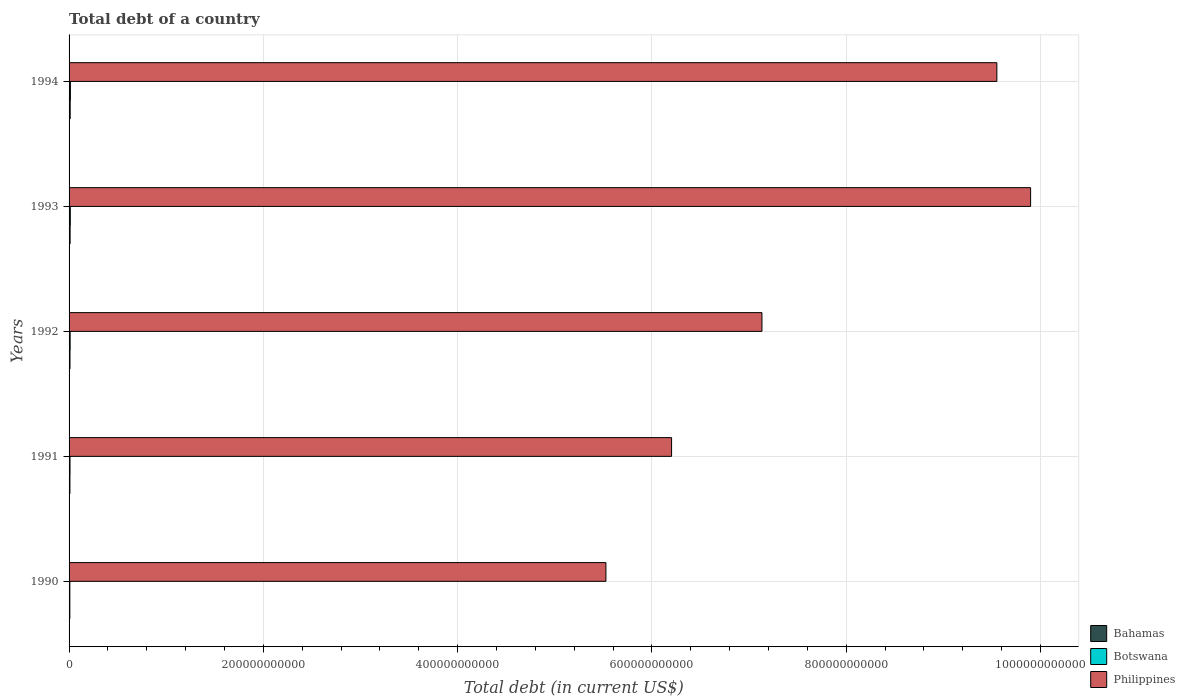How many different coloured bars are there?
Your answer should be very brief. 3. How many groups of bars are there?
Make the answer very short. 5. Are the number of bars per tick equal to the number of legend labels?
Provide a succinct answer. Yes. Are the number of bars on each tick of the Y-axis equal?
Your answer should be very brief. Yes. How many bars are there on the 5th tick from the top?
Make the answer very short. 3. What is the label of the 5th group of bars from the top?
Provide a short and direct response. 1990. In how many cases, is the number of bars for a given year not equal to the number of legend labels?
Offer a very short reply. 0. What is the debt in Bahamas in 1994?
Your response must be concise. 1.14e+09. Across all years, what is the maximum debt in Botswana?
Keep it short and to the point. 1.38e+09. Across all years, what is the minimum debt in Philippines?
Your answer should be very brief. 5.53e+11. In which year was the debt in Botswana maximum?
Make the answer very short. 1994. What is the total debt in Philippines in the graph?
Keep it short and to the point. 3.83e+12. What is the difference between the debt in Botswana in 1990 and that in 1993?
Offer a very short reply. -4.53e+08. What is the difference between the debt in Botswana in 1990 and the debt in Bahamas in 1994?
Offer a very short reply. -3.34e+08. What is the average debt in Botswana per year?
Offer a very short reply. 1.10e+09. In the year 1993, what is the difference between the debt in Bahamas and debt in Philippines?
Offer a very short reply. -9.89e+11. In how many years, is the debt in Botswana greater than 640000000000 US$?
Provide a succinct answer. 0. What is the ratio of the debt in Philippines in 1991 to that in 1992?
Your answer should be very brief. 0.87. Is the debt in Botswana in 1993 less than that in 1994?
Keep it short and to the point. Yes. What is the difference between the highest and the second highest debt in Philippines?
Give a very brief answer. 3.47e+1. What is the difference between the highest and the lowest debt in Philippines?
Make the answer very short. 4.37e+11. Is the sum of the debt in Botswana in 1993 and 1994 greater than the maximum debt in Philippines across all years?
Keep it short and to the point. No. What does the 1st bar from the top in 1993 represents?
Keep it short and to the point. Philippines. What does the 2nd bar from the bottom in 1993 represents?
Keep it short and to the point. Botswana. Are all the bars in the graph horizontal?
Ensure brevity in your answer.  Yes. What is the difference between two consecutive major ticks on the X-axis?
Provide a succinct answer. 2.00e+11. Are the values on the major ticks of X-axis written in scientific E-notation?
Provide a succinct answer. No. How many legend labels are there?
Your answer should be very brief. 3. What is the title of the graph?
Keep it short and to the point. Total debt of a country. What is the label or title of the X-axis?
Ensure brevity in your answer.  Total debt (in current US$). What is the label or title of the Y-axis?
Your response must be concise. Years. What is the Total debt (in current US$) of Bahamas in 1990?
Offer a terse response. 7.73e+08. What is the Total debt (in current US$) of Botswana in 1990?
Provide a short and direct response. 8.02e+08. What is the Total debt (in current US$) in Philippines in 1990?
Offer a very short reply. 5.53e+11. What is the Total debt (in current US$) of Bahamas in 1991?
Keep it short and to the point. 8.70e+08. What is the Total debt (in current US$) in Botswana in 1991?
Provide a short and direct response. 9.66e+08. What is the Total debt (in current US$) of Philippines in 1991?
Provide a succinct answer. 6.20e+11. What is the Total debt (in current US$) of Bahamas in 1992?
Your answer should be compact. 9.52e+08. What is the Total debt (in current US$) of Botswana in 1992?
Offer a very short reply. 1.10e+09. What is the Total debt (in current US$) in Philippines in 1992?
Make the answer very short. 7.13e+11. What is the Total debt (in current US$) of Bahamas in 1993?
Give a very brief answer. 1.06e+09. What is the Total debt (in current US$) of Botswana in 1993?
Give a very brief answer. 1.25e+09. What is the Total debt (in current US$) of Philippines in 1993?
Make the answer very short. 9.90e+11. What is the Total debt (in current US$) in Bahamas in 1994?
Your response must be concise. 1.14e+09. What is the Total debt (in current US$) of Botswana in 1994?
Offer a very short reply. 1.38e+09. What is the Total debt (in current US$) of Philippines in 1994?
Your answer should be compact. 9.55e+11. Across all years, what is the maximum Total debt (in current US$) of Bahamas?
Offer a very short reply. 1.14e+09. Across all years, what is the maximum Total debt (in current US$) of Botswana?
Your answer should be very brief. 1.38e+09. Across all years, what is the maximum Total debt (in current US$) in Philippines?
Give a very brief answer. 9.90e+11. Across all years, what is the minimum Total debt (in current US$) in Bahamas?
Offer a terse response. 7.73e+08. Across all years, what is the minimum Total debt (in current US$) of Botswana?
Provide a succinct answer. 8.02e+08. Across all years, what is the minimum Total debt (in current US$) of Philippines?
Keep it short and to the point. 5.53e+11. What is the total Total debt (in current US$) of Bahamas in the graph?
Offer a very short reply. 4.80e+09. What is the total Total debt (in current US$) of Botswana in the graph?
Your response must be concise. 5.50e+09. What is the total Total debt (in current US$) of Philippines in the graph?
Offer a very short reply. 3.83e+12. What is the difference between the Total debt (in current US$) of Bahamas in 1990 and that in 1991?
Provide a succinct answer. -9.73e+07. What is the difference between the Total debt (in current US$) of Botswana in 1990 and that in 1991?
Provide a succinct answer. -1.64e+08. What is the difference between the Total debt (in current US$) of Philippines in 1990 and that in 1991?
Provide a short and direct response. -6.76e+1. What is the difference between the Total debt (in current US$) in Bahamas in 1990 and that in 1992?
Give a very brief answer. -1.79e+08. What is the difference between the Total debt (in current US$) of Botswana in 1990 and that in 1992?
Your response must be concise. -2.94e+08. What is the difference between the Total debt (in current US$) of Philippines in 1990 and that in 1992?
Ensure brevity in your answer.  -1.61e+11. What is the difference between the Total debt (in current US$) of Bahamas in 1990 and that in 1993?
Give a very brief answer. -2.92e+08. What is the difference between the Total debt (in current US$) in Botswana in 1990 and that in 1993?
Provide a short and direct response. -4.53e+08. What is the difference between the Total debt (in current US$) of Philippines in 1990 and that in 1993?
Keep it short and to the point. -4.37e+11. What is the difference between the Total debt (in current US$) of Bahamas in 1990 and that in 1994?
Ensure brevity in your answer.  -3.63e+08. What is the difference between the Total debt (in current US$) in Botswana in 1990 and that in 1994?
Keep it short and to the point. -5.75e+08. What is the difference between the Total debt (in current US$) of Philippines in 1990 and that in 1994?
Your response must be concise. -4.02e+11. What is the difference between the Total debt (in current US$) of Bahamas in 1991 and that in 1992?
Make the answer very short. -8.19e+07. What is the difference between the Total debt (in current US$) in Botswana in 1991 and that in 1992?
Provide a short and direct response. -1.30e+08. What is the difference between the Total debt (in current US$) of Philippines in 1991 and that in 1992?
Provide a succinct answer. -9.30e+1. What is the difference between the Total debt (in current US$) in Bahamas in 1991 and that in 1993?
Your response must be concise. -1.94e+08. What is the difference between the Total debt (in current US$) in Botswana in 1991 and that in 1993?
Your response must be concise. -2.89e+08. What is the difference between the Total debt (in current US$) in Philippines in 1991 and that in 1993?
Keep it short and to the point. -3.70e+11. What is the difference between the Total debt (in current US$) in Bahamas in 1991 and that in 1994?
Offer a terse response. -2.66e+08. What is the difference between the Total debt (in current US$) in Botswana in 1991 and that in 1994?
Provide a short and direct response. -4.11e+08. What is the difference between the Total debt (in current US$) in Philippines in 1991 and that in 1994?
Give a very brief answer. -3.35e+11. What is the difference between the Total debt (in current US$) in Bahamas in 1992 and that in 1993?
Keep it short and to the point. -1.12e+08. What is the difference between the Total debt (in current US$) in Botswana in 1992 and that in 1993?
Keep it short and to the point. -1.58e+08. What is the difference between the Total debt (in current US$) in Philippines in 1992 and that in 1993?
Offer a very short reply. -2.77e+11. What is the difference between the Total debt (in current US$) of Bahamas in 1992 and that in 1994?
Ensure brevity in your answer.  -1.84e+08. What is the difference between the Total debt (in current US$) of Botswana in 1992 and that in 1994?
Your answer should be compact. -2.81e+08. What is the difference between the Total debt (in current US$) of Philippines in 1992 and that in 1994?
Give a very brief answer. -2.42e+11. What is the difference between the Total debt (in current US$) of Bahamas in 1993 and that in 1994?
Make the answer very short. -7.16e+07. What is the difference between the Total debt (in current US$) in Botswana in 1993 and that in 1994?
Keep it short and to the point. -1.22e+08. What is the difference between the Total debt (in current US$) of Philippines in 1993 and that in 1994?
Give a very brief answer. 3.47e+1. What is the difference between the Total debt (in current US$) in Bahamas in 1990 and the Total debt (in current US$) in Botswana in 1991?
Your answer should be very brief. -1.93e+08. What is the difference between the Total debt (in current US$) of Bahamas in 1990 and the Total debt (in current US$) of Philippines in 1991?
Give a very brief answer. -6.19e+11. What is the difference between the Total debt (in current US$) of Botswana in 1990 and the Total debt (in current US$) of Philippines in 1991?
Provide a succinct answer. -6.19e+11. What is the difference between the Total debt (in current US$) in Bahamas in 1990 and the Total debt (in current US$) in Botswana in 1992?
Offer a terse response. -3.23e+08. What is the difference between the Total debt (in current US$) in Bahamas in 1990 and the Total debt (in current US$) in Philippines in 1992?
Provide a short and direct response. -7.12e+11. What is the difference between the Total debt (in current US$) in Botswana in 1990 and the Total debt (in current US$) in Philippines in 1992?
Your response must be concise. -7.12e+11. What is the difference between the Total debt (in current US$) of Bahamas in 1990 and the Total debt (in current US$) of Botswana in 1993?
Give a very brief answer. -4.81e+08. What is the difference between the Total debt (in current US$) of Bahamas in 1990 and the Total debt (in current US$) of Philippines in 1993?
Your response must be concise. -9.89e+11. What is the difference between the Total debt (in current US$) of Botswana in 1990 and the Total debt (in current US$) of Philippines in 1993?
Provide a succinct answer. -9.89e+11. What is the difference between the Total debt (in current US$) in Bahamas in 1990 and the Total debt (in current US$) in Botswana in 1994?
Offer a terse response. -6.04e+08. What is the difference between the Total debt (in current US$) of Bahamas in 1990 and the Total debt (in current US$) of Philippines in 1994?
Your answer should be very brief. -9.54e+11. What is the difference between the Total debt (in current US$) of Botswana in 1990 and the Total debt (in current US$) of Philippines in 1994?
Your response must be concise. -9.54e+11. What is the difference between the Total debt (in current US$) of Bahamas in 1991 and the Total debt (in current US$) of Botswana in 1992?
Provide a succinct answer. -2.26e+08. What is the difference between the Total debt (in current US$) of Bahamas in 1991 and the Total debt (in current US$) of Philippines in 1992?
Make the answer very short. -7.12e+11. What is the difference between the Total debt (in current US$) of Botswana in 1991 and the Total debt (in current US$) of Philippines in 1992?
Your answer should be compact. -7.12e+11. What is the difference between the Total debt (in current US$) of Bahamas in 1991 and the Total debt (in current US$) of Botswana in 1993?
Your answer should be very brief. -3.84e+08. What is the difference between the Total debt (in current US$) of Bahamas in 1991 and the Total debt (in current US$) of Philippines in 1993?
Provide a short and direct response. -9.89e+11. What is the difference between the Total debt (in current US$) in Botswana in 1991 and the Total debt (in current US$) in Philippines in 1993?
Provide a succinct answer. -9.89e+11. What is the difference between the Total debt (in current US$) in Bahamas in 1991 and the Total debt (in current US$) in Botswana in 1994?
Ensure brevity in your answer.  -5.07e+08. What is the difference between the Total debt (in current US$) in Bahamas in 1991 and the Total debt (in current US$) in Philippines in 1994?
Offer a terse response. -9.54e+11. What is the difference between the Total debt (in current US$) in Botswana in 1991 and the Total debt (in current US$) in Philippines in 1994?
Ensure brevity in your answer.  -9.54e+11. What is the difference between the Total debt (in current US$) in Bahamas in 1992 and the Total debt (in current US$) in Botswana in 1993?
Give a very brief answer. -3.02e+08. What is the difference between the Total debt (in current US$) of Bahamas in 1992 and the Total debt (in current US$) of Philippines in 1993?
Provide a short and direct response. -9.89e+11. What is the difference between the Total debt (in current US$) of Botswana in 1992 and the Total debt (in current US$) of Philippines in 1993?
Give a very brief answer. -9.89e+11. What is the difference between the Total debt (in current US$) in Bahamas in 1992 and the Total debt (in current US$) in Botswana in 1994?
Provide a short and direct response. -4.25e+08. What is the difference between the Total debt (in current US$) of Bahamas in 1992 and the Total debt (in current US$) of Philippines in 1994?
Your answer should be compact. -9.54e+11. What is the difference between the Total debt (in current US$) in Botswana in 1992 and the Total debt (in current US$) in Philippines in 1994?
Provide a short and direct response. -9.54e+11. What is the difference between the Total debt (in current US$) of Bahamas in 1993 and the Total debt (in current US$) of Botswana in 1994?
Your response must be concise. -3.12e+08. What is the difference between the Total debt (in current US$) in Bahamas in 1993 and the Total debt (in current US$) in Philippines in 1994?
Give a very brief answer. -9.54e+11. What is the difference between the Total debt (in current US$) in Botswana in 1993 and the Total debt (in current US$) in Philippines in 1994?
Your answer should be compact. -9.54e+11. What is the average Total debt (in current US$) of Bahamas per year?
Offer a very short reply. 9.59e+08. What is the average Total debt (in current US$) of Botswana per year?
Keep it short and to the point. 1.10e+09. What is the average Total debt (in current US$) in Philippines per year?
Provide a succinct answer. 7.66e+11. In the year 1990, what is the difference between the Total debt (in current US$) in Bahamas and Total debt (in current US$) in Botswana?
Offer a terse response. -2.88e+07. In the year 1990, what is the difference between the Total debt (in current US$) of Bahamas and Total debt (in current US$) of Philippines?
Keep it short and to the point. -5.52e+11. In the year 1990, what is the difference between the Total debt (in current US$) of Botswana and Total debt (in current US$) of Philippines?
Make the answer very short. -5.52e+11. In the year 1991, what is the difference between the Total debt (in current US$) of Bahamas and Total debt (in current US$) of Botswana?
Your answer should be compact. -9.54e+07. In the year 1991, what is the difference between the Total debt (in current US$) of Bahamas and Total debt (in current US$) of Philippines?
Offer a terse response. -6.19e+11. In the year 1991, what is the difference between the Total debt (in current US$) in Botswana and Total debt (in current US$) in Philippines?
Your answer should be very brief. -6.19e+11. In the year 1992, what is the difference between the Total debt (in current US$) of Bahamas and Total debt (in current US$) of Botswana?
Ensure brevity in your answer.  -1.44e+08. In the year 1992, what is the difference between the Total debt (in current US$) of Bahamas and Total debt (in current US$) of Philippines?
Provide a succinct answer. -7.12e+11. In the year 1992, what is the difference between the Total debt (in current US$) of Botswana and Total debt (in current US$) of Philippines?
Give a very brief answer. -7.12e+11. In the year 1993, what is the difference between the Total debt (in current US$) of Bahamas and Total debt (in current US$) of Botswana?
Offer a terse response. -1.90e+08. In the year 1993, what is the difference between the Total debt (in current US$) of Bahamas and Total debt (in current US$) of Philippines?
Your answer should be compact. -9.89e+11. In the year 1993, what is the difference between the Total debt (in current US$) of Botswana and Total debt (in current US$) of Philippines?
Give a very brief answer. -9.89e+11. In the year 1994, what is the difference between the Total debt (in current US$) in Bahamas and Total debt (in current US$) in Botswana?
Your response must be concise. -2.41e+08. In the year 1994, what is the difference between the Total debt (in current US$) of Bahamas and Total debt (in current US$) of Philippines?
Provide a short and direct response. -9.54e+11. In the year 1994, what is the difference between the Total debt (in current US$) in Botswana and Total debt (in current US$) in Philippines?
Ensure brevity in your answer.  -9.54e+11. What is the ratio of the Total debt (in current US$) in Bahamas in 1990 to that in 1991?
Give a very brief answer. 0.89. What is the ratio of the Total debt (in current US$) of Botswana in 1990 to that in 1991?
Keep it short and to the point. 0.83. What is the ratio of the Total debt (in current US$) in Philippines in 1990 to that in 1991?
Your response must be concise. 0.89. What is the ratio of the Total debt (in current US$) of Bahamas in 1990 to that in 1992?
Your answer should be compact. 0.81. What is the ratio of the Total debt (in current US$) of Botswana in 1990 to that in 1992?
Provide a short and direct response. 0.73. What is the ratio of the Total debt (in current US$) in Philippines in 1990 to that in 1992?
Ensure brevity in your answer.  0.77. What is the ratio of the Total debt (in current US$) in Bahamas in 1990 to that in 1993?
Offer a terse response. 0.73. What is the ratio of the Total debt (in current US$) in Botswana in 1990 to that in 1993?
Keep it short and to the point. 0.64. What is the ratio of the Total debt (in current US$) in Philippines in 1990 to that in 1993?
Offer a terse response. 0.56. What is the ratio of the Total debt (in current US$) in Bahamas in 1990 to that in 1994?
Offer a very short reply. 0.68. What is the ratio of the Total debt (in current US$) of Botswana in 1990 to that in 1994?
Offer a terse response. 0.58. What is the ratio of the Total debt (in current US$) of Philippines in 1990 to that in 1994?
Provide a short and direct response. 0.58. What is the ratio of the Total debt (in current US$) in Bahamas in 1991 to that in 1992?
Your answer should be very brief. 0.91. What is the ratio of the Total debt (in current US$) of Botswana in 1991 to that in 1992?
Provide a succinct answer. 0.88. What is the ratio of the Total debt (in current US$) in Philippines in 1991 to that in 1992?
Keep it short and to the point. 0.87. What is the ratio of the Total debt (in current US$) in Bahamas in 1991 to that in 1993?
Your response must be concise. 0.82. What is the ratio of the Total debt (in current US$) in Botswana in 1991 to that in 1993?
Give a very brief answer. 0.77. What is the ratio of the Total debt (in current US$) in Philippines in 1991 to that in 1993?
Provide a short and direct response. 0.63. What is the ratio of the Total debt (in current US$) of Bahamas in 1991 to that in 1994?
Give a very brief answer. 0.77. What is the ratio of the Total debt (in current US$) in Botswana in 1991 to that in 1994?
Your answer should be very brief. 0.7. What is the ratio of the Total debt (in current US$) in Philippines in 1991 to that in 1994?
Offer a very short reply. 0.65. What is the ratio of the Total debt (in current US$) of Bahamas in 1992 to that in 1993?
Your response must be concise. 0.89. What is the ratio of the Total debt (in current US$) of Botswana in 1992 to that in 1993?
Your answer should be very brief. 0.87. What is the ratio of the Total debt (in current US$) in Philippines in 1992 to that in 1993?
Your answer should be compact. 0.72. What is the ratio of the Total debt (in current US$) of Bahamas in 1992 to that in 1994?
Your answer should be very brief. 0.84. What is the ratio of the Total debt (in current US$) in Botswana in 1992 to that in 1994?
Your response must be concise. 0.8. What is the ratio of the Total debt (in current US$) in Philippines in 1992 to that in 1994?
Give a very brief answer. 0.75. What is the ratio of the Total debt (in current US$) in Bahamas in 1993 to that in 1994?
Your answer should be compact. 0.94. What is the ratio of the Total debt (in current US$) in Botswana in 1993 to that in 1994?
Your answer should be compact. 0.91. What is the ratio of the Total debt (in current US$) of Philippines in 1993 to that in 1994?
Your response must be concise. 1.04. What is the difference between the highest and the second highest Total debt (in current US$) in Bahamas?
Give a very brief answer. 7.16e+07. What is the difference between the highest and the second highest Total debt (in current US$) in Botswana?
Keep it short and to the point. 1.22e+08. What is the difference between the highest and the second highest Total debt (in current US$) in Philippines?
Ensure brevity in your answer.  3.47e+1. What is the difference between the highest and the lowest Total debt (in current US$) of Bahamas?
Your answer should be very brief. 3.63e+08. What is the difference between the highest and the lowest Total debt (in current US$) of Botswana?
Offer a very short reply. 5.75e+08. What is the difference between the highest and the lowest Total debt (in current US$) in Philippines?
Make the answer very short. 4.37e+11. 